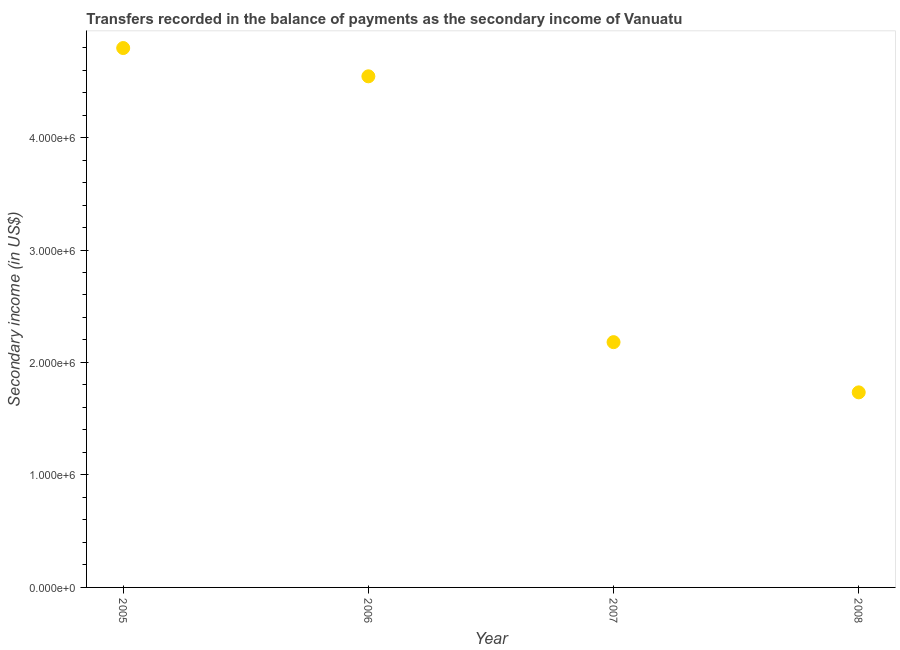What is the amount of secondary income in 2008?
Provide a succinct answer. 1.73e+06. Across all years, what is the maximum amount of secondary income?
Provide a short and direct response. 4.80e+06. Across all years, what is the minimum amount of secondary income?
Your response must be concise. 1.73e+06. In which year was the amount of secondary income minimum?
Offer a terse response. 2008. What is the sum of the amount of secondary income?
Offer a terse response. 1.33e+07. What is the difference between the amount of secondary income in 2005 and 2007?
Provide a succinct answer. 2.61e+06. What is the average amount of secondary income per year?
Provide a succinct answer. 3.31e+06. What is the median amount of secondary income?
Your answer should be compact. 3.36e+06. Do a majority of the years between 2005 and 2006 (inclusive) have amount of secondary income greater than 600000 US$?
Your response must be concise. Yes. What is the ratio of the amount of secondary income in 2007 to that in 2008?
Offer a very short reply. 1.26. Is the amount of secondary income in 2005 less than that in 2007?
Your answer should be compact. No. What is the difference between the highest and the second highest amount of secondary income?
Your response must be concise. 2.51e+05. Is the sum of the amount of secondary income in 2006 and 2007 greater than the maximum amount of secondary income across all years?
Offer a terse response. Yes. What is the difference between the highest and the lowest amount of secondary income?
Make the answer very short. 3.06e+06. In how many years, is the amount of secondary income greater than the average amount of secondary income taken over all years?
Your answer should be very brief. 2. Does the amount of secondary income monotonically increase over the years?
Offer a very short reply. No. How many dotlines are there?
Make the answer very short. 1. Are the values on the major ticks of Y-axis written in scientific E-notation?
Make the answer very short. Yes. Does the graph contain any zero values?
Ensure brevity in your answer.  No. What is the title of the graph?
Ensure brevity in your answer.  Transfers recorded in the balance of payments as the secondary income of Vanuatu. What is the label or title of the Y-axis?
Provide a succinct answer. Secondary income (in US$). What is the Secondary income (in US$) in 2005?
Offer a very short reply. 4.80e+06. What is the Secondary income (in US$) in 2006?
Offer a very short reply. 4.54e+06. What is the Secondary income (in US$) in 2007?
Give a very brief answer. 2.18e+06. What is the Secondary income (in US$) in 2008?
Your response must be concise. 1.73e+06. What is the difference between the Secondary income (in US$) in 2005 and 2006?
Make the answer very short. 2.51e+05. What is the difference between the Secondary income (in US$) in 2005 and 2007?
Provide a short and direct response. 2.61e+06. What is the difference between the Secondary income (in US$) in 2005 and 2008?
Offer a terse response. 3.06e+06. What is the difference between the Secondary income (in US$) in 2006 and 2007?
Provide a short and direct response. 2.36e+06. What is the difference between the Secondary income (in US$) in 2006 and 2008?
Your answer should be very brief. 2.81e+06. What is the difference between the Secondary income (in US$) in 2007 and 2008?
Give a very brief answer. 4.47e+05. What is the ratio of the Secondary income (in US$) in 2005 to that in 2006?
Provide a succinct answer. 1.05. What is the ratio of the Secondary income (in US$) in 2005 to that in 2007?
Provide a succinct answer. 2.2. What is the ratio of the Secondary income (in US$) in 2005 to that in 2008?
Provide a succinct answer. 2.77. What is the ratio of the Secondary income (in US$) in 2006 to that in 2007?
Your answer should be very brief. 2.08. What is the ratio of the Secondary income (in US$) in 2006 to that in 2008?
Your answer should be compact. 2.62. What is the ratio of the Secondary income (in US$) in 2007 to that in 2008?
Offer a terse response. 1.26. 